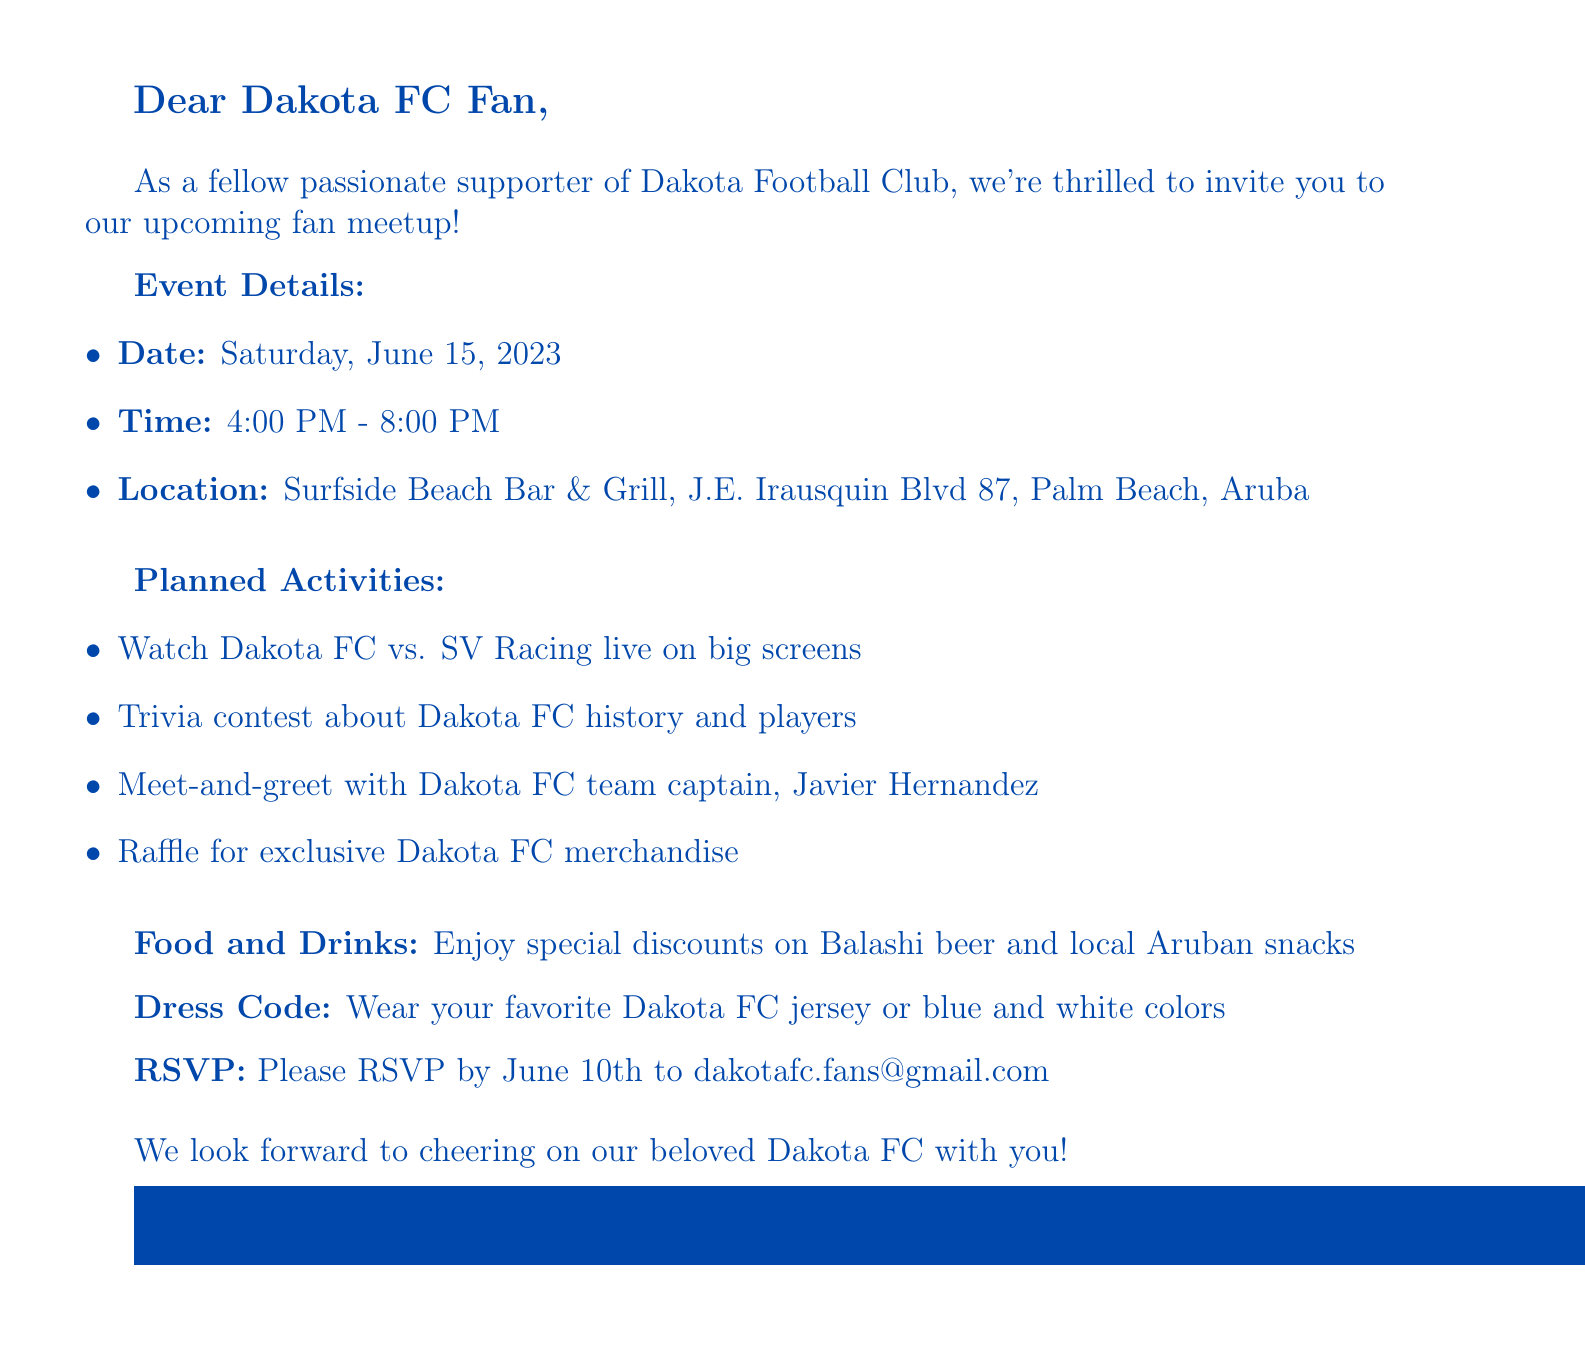What is the date of the meetup? The document specifies that the meetup will take place on Saturday, June 15, 2023.
Answer: Saturday, June 15, 2023 What time does the event start? The event details mention that it will start at 4:00 PM.
Answer: 4:00 PM Where is the meetup location? The location provided in the document is Surfside Beach Bar & Grill, J.E. Irausquin Blvd 87, Palm Beach, Aruba.
Answer: Surfside Beach Bar & Grill, J.E. Irausquin Blvd 87, Palm Beach, Aruba Who is the Dakota FC team captain attending the meetup? The document states that the team captain who will be present is Javier Hernandez.
Answer: Javier Hernandez What special discount is offered at the event? According to the document, there is a special discount on Balashi beer.
Answer: Balashi beer What activity involves a contest about Dakota FC? The planned activities include a trivia contest about Dakota FC history and players.
Answer: Trivia contest What is the RSVP deadline? The RSVP information gives a deadline of June 10th.
Answer: June 10th What should attendees wear to the meetup? The dress code specifies that attendees should wear their favorite Dakota FC jersey or blue and white colors.
Answer: Dakota FC jersey or blue and white colors 